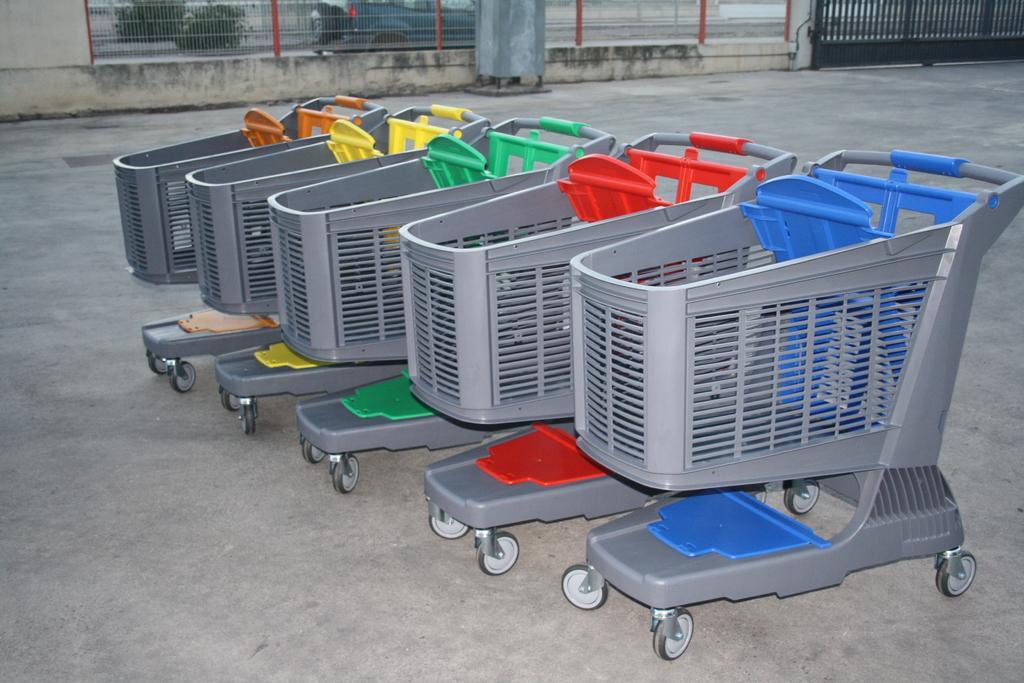Could you give a brief overview of what you see in this image? In this image we can see trolleys, there is a gate, fencing, plants, and a vehicle, also we can see the wall. 